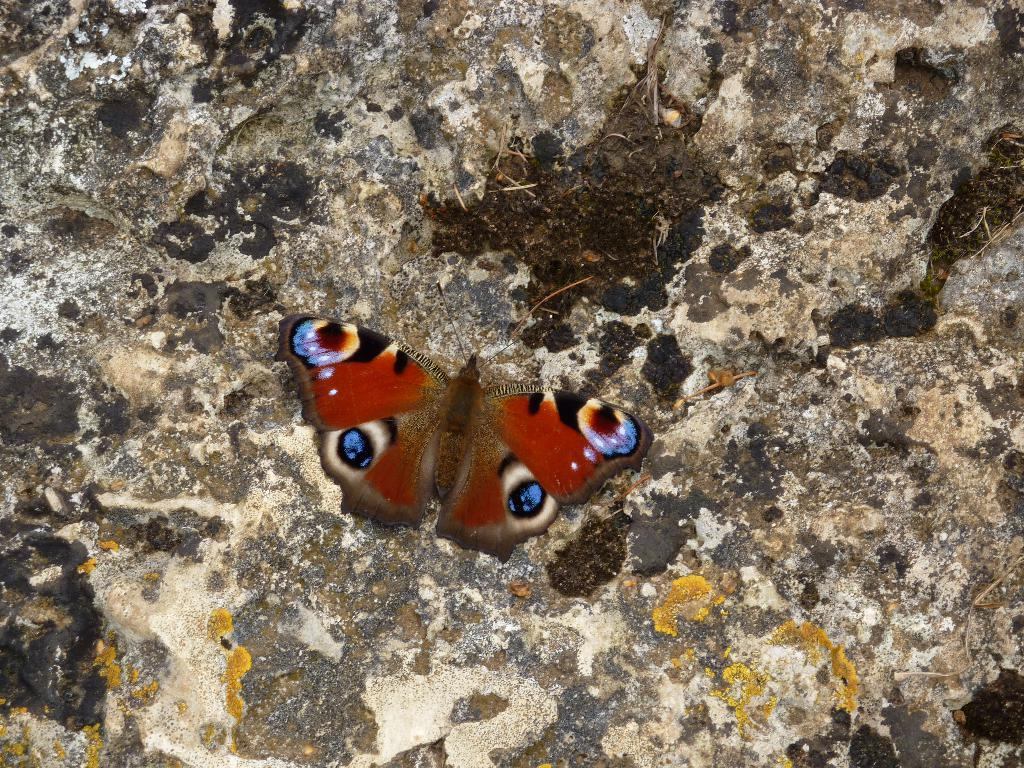What type of animal can be seen in the image? There is a butterfly in the image. Where is the butterfly located? The butterfly is on a surface. What type of plants can be seen in the store in the image? There is no store or plants present in the image; it features a butterfly on a surface. What type of gun is visible in the image? There is no gun present in the image; it features a butterfly on a surface. 